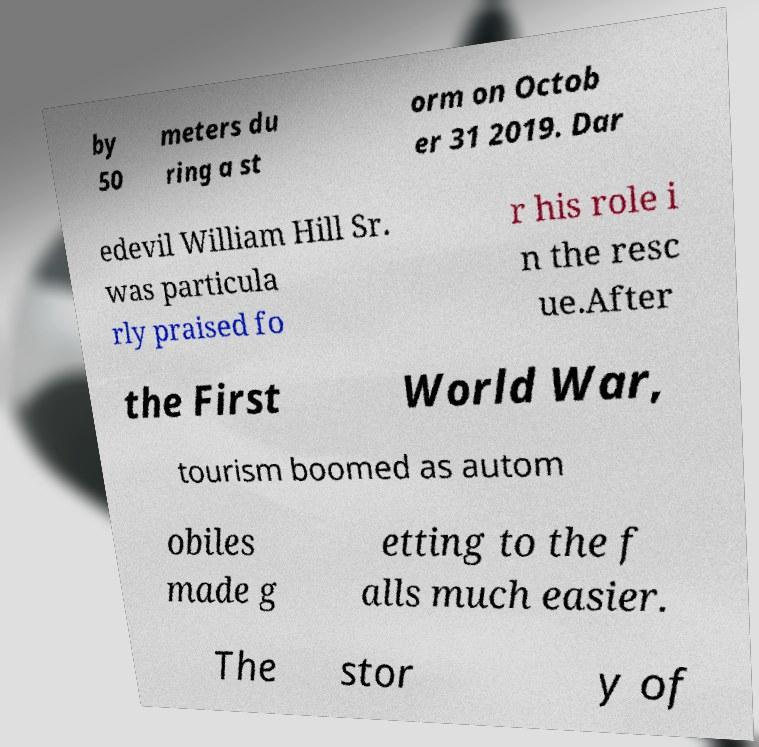Could you extract and type out the text from this image? by 50 meters du ring a st orm on Octob er 31 2019. Dar edevil William Hill Sr. was particula rly praised fo r his role i n the resc ue.After the First World War, tourism boomed as autom obiles made g etting to the f alls much easier. The stor y of 